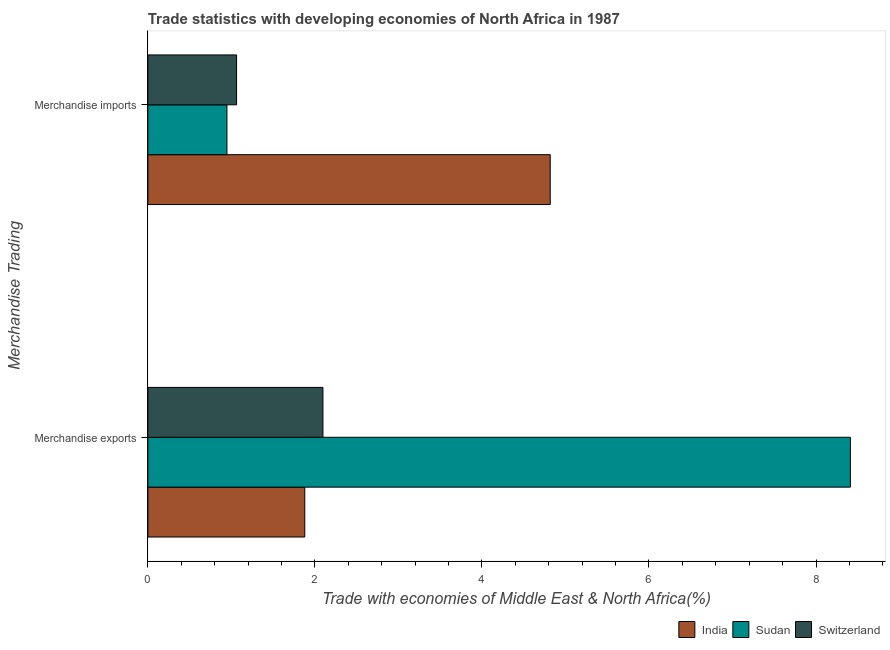How many groups of bars are there?
Give a very brief answer. 2. Are the number of bars per tick equal to the number of legend labels?
Keep it short and to the point. Yes. How many bars are there on the 2nd tick from the bottom?
Offer a terse response. 3. What is the merchandise exports in India?
Offer a very short reply. 1.88. Across all countries, what is the maximum merchandise exports?
Offer a very short reply. 8.41. Across all countries, what is the minimum merchandise imports?
Provide a short and direct response. 0.95. In which country was the merchandise exports maximum?
Provide a short and direct response. Sudan. In which country was the merchandise exports minimum?
Offer a terse response. India. What is the total merchandise exports in the graph?
Give a very brief answer. 12.39. What is the difference between the merchandise imports in Switzerland and that in India?
Ensure brevity in your answer.  -3.76. What is the difference between the merchandise exports in Switzerland and the merchandise imports in India?
Give a very brief answer. -2.72. What is the average merchandise imports per country?
Offer a very short reply. 2.28. What is the difference between the merchandise imports and merchandise exports in Sudan?
Give a very brief answer. -7.46. What is the ratio of the merchandise imports in India to that in Switzerland?
Your response must be concise. 4.54. Is the merchandise exports in Switzerland less than that in Sudan?
Provide a short and direct response. Yes. What does the 1st bar from the top in Merchandise imports represents?
Keep it short and to the point. Switzerland. What does the 1st bar from the bottom in Merchandise imports represents?
Ensure brevity in your answer.  India. How many countries are there in the graph?
Provide a succinct answer. 3. Does the graph contain any zero values?
Keep it short and to the point. No. Where does the legend appear in the graph?
Your response must be concise. Bottom right. What is the title of the graph?
Offer a very short reply. Trade statistics with developing economies of North Africa in 1987. What is the label or title of the X-axis?
Offer a terse response. Trade with economies of Middle East & North Africa(%). What is the label or title of the Y-axis?
Provide a short and direct response. Merchandise Trading. What is the Trade with economies of Middle East & North Africa(%) in India in Merchandise exports?
Keep it short and to the point. 1.88. What is the Trade with economies of Middle East & North Africa(%) in Sudan in Merchandise exports?
Offer a terse response. 8.41. What is the Trade with economies of Middle East & North Africa(%) of Switzerland in Merchandise exports?
Your response must be concise. 2.1. What is the Trade with economies of Middle East & North Africa(%) of India in Merchandise imports?
Keep it short and to the point. 4.82. What is the Trade with economies of Middle East & North Africa(%) in Sudan in Merchandise imports?
Keep it short and to the point. 0.95. What is the Trade with economies of Middle East & North Africa(%) of Switzerland in Merchandise imports?
Your answer should be very brief. 1.06. Across all Merchandise Trading, what is the maximum Trade with economies of Middle East & North Africa(%) of India?
Keep it short and to the point. 4.82. Across all Merchandise Trading, what is the maximum Trade with economies of Middle East & North Africa(%) of Sudan?
Offer a terse response. 8.41. Across all Merchandise Trading, what is the maximum Trade with economies of Middle East & North Africa(%) in Switzerland?
Your answer should be compact. 2.1. Across all Merchandise Trading, what is the minimum Trade with economies of Middle East & North Africa(%) of India?
Offer a very short reply. 1.88. Across all Merchandise Trading, what is the minimum Trade with economies of Middle East & North Africa(%) in Sudan?
Your answer should be very brief. 0.95. Across all Merchandise Trading, what is the minimum Trade with economies of Middle East & North Africa(%) of Switzerland?
Make the answer very short. 1.06. What is the total Trade with economies of Middle East & North Africa(%) of India in the graph?
Keep it short and to the point. 6.7. What is the total Trade with economies of Middle East & North Africa(%) in Sudan in the graph?
Your answer should be very brief. 9.36. What is the total Trade with economies of Middle East & North Africa(%) in Switzerland in the graph?
Offer a terse response. 3.16. What is the difference between the Trade with economies of Middle East & North Africa(%) of India in Merchandise exports and that in Merchandise imports?
Provide a succinct answer. -2.94. What is the difference between the Trade with economies of Middle East & North Africa(%) of Sudan in Merchandise exports and that in Merchandise imports?
Make the answer very short. 7.46. What is the difference between the Trade with economies of Middle East & North Africa(%) in Switzerland in Merchandise exports and that in Merchandise imports?
Your response must be concise. 1.03. What is the difference between the Trade with economies of Middle East & North Africa(%) of India in Merchandise exports and the Trade with economies of Middle East & North Africa(%) of Sudan in Merchandise imports?
Make the answer very short. 0.93. What is the difference between the Trade with economies of Middle East & North Africa(%) in India in Merchandise exports and the Trade with economies of Middle East & North Africa(%) in Switzerland in Merchandise imports?
Offer a terse response. 0.82. What is the difference between the Trade with economies of Middle East & North Africa(%) of Sudan in Merchandise exports and the Trade with economies of Middle East & North Africa(%) of Switzerland in Merchandise imports?
Offer a terse response. 7.35. What is the average Trade with economies of Middle East & North Africa(%) in India per Merchandise Trading?
Your answer should be compact. 3.35. What is the average Trade with economies of Middle East & North Africa(%) of Sudan per Merchandise Trading?
Your answer should be very brief. 4.68. What is the average Trade with economies of Middle East & North Africa(%) in Switzerland per Merchandise Trading?
Your response must be concise. 1.58. What is the difference between the Trade with economies of Middle East & North Africa(%) in India and Trade with economies of Middle East & North Africa(%) in Sudan in Merchandise exports?
Your answer should be very brief. -6.53. What is the difference between the Trade with economies of Middle East & North Africa(%) in India and Trade with economies of Middle East & North Africa(%) in Switzerland in Merchandise exports?
Your answer should be compact. -0.22. What is the difference between the Trade with economies of Middle East & North Africa(%) of Sudan and Trade with economies of Middle East & North Africa(%) of Switzerland in Merchandise exports?
Ensure brevity in your answer.  6.32. What is the difference between the Trade with economies of Middle East & North Africa(%) in India and Trade with economies of Middle East & North Africa(%) in Sudan in Merchandise imports?
Provide a short and direct response. 3.87. What is the difference between the Trade with economies of Middle East & North Africa(%) in India and Trade with economies of Middle East & North Africa(%) in Switzerland in Merchandise imports?
Offer a very short reply. 3.76. What is the difference between the Trade with economies of Middle East & North Africa(%) of Sudan and Trade with economies of Middle East & North Africa(%) of Switzerland in Merchandise imports?
Keep it short and to the point. -0.12. What is the ratio of the Trade with economies of Middle East & North Africa(%) in India in Merchandise exports to that in Merchandise imports?
Keep it short and to the point. 0.39. What is the ratio of the Trade with economies of Middle East & North Africa(%) of Sudan in Merchandise exports to that in Merchandise imports?
Your response must be concise. 8.88. What is the ratio of the Trade with economies of Middle East & North Africa(%) in Switzerland in Merchandise exports to that in Merchandise imports?
Make the answer very short. 1.97. What is the difference between the highest and the second highest Trade with economies of Middle East & North Africa(%) of India?
Give a very brief answer. 2.94. What is the difference between the highest and the second highest Trade with economies of Middle East & North Africa(%) in Sudan?
Offer a terse response. 7.46. What is the difference between the highest and the second highest Trade with economies of Middle East & North Africa(%) in Switzerland?
Your answer should be compact. 1.03. What is the difference between the highest and the lowest Trade with economies of Middle East & North Africa(%) of India?
Provide a succinct answer. 2.94. What is the difference between the highest and the lowest Trade with economies of Middle East & North Africa(%) in Sudan?
Your response must be concise. 7.46. What is the difference between the highest and the lowest Trade with economies of Middle East & North Africa(%) in Switzerland?
Keep it short and to the point. 1.03. 